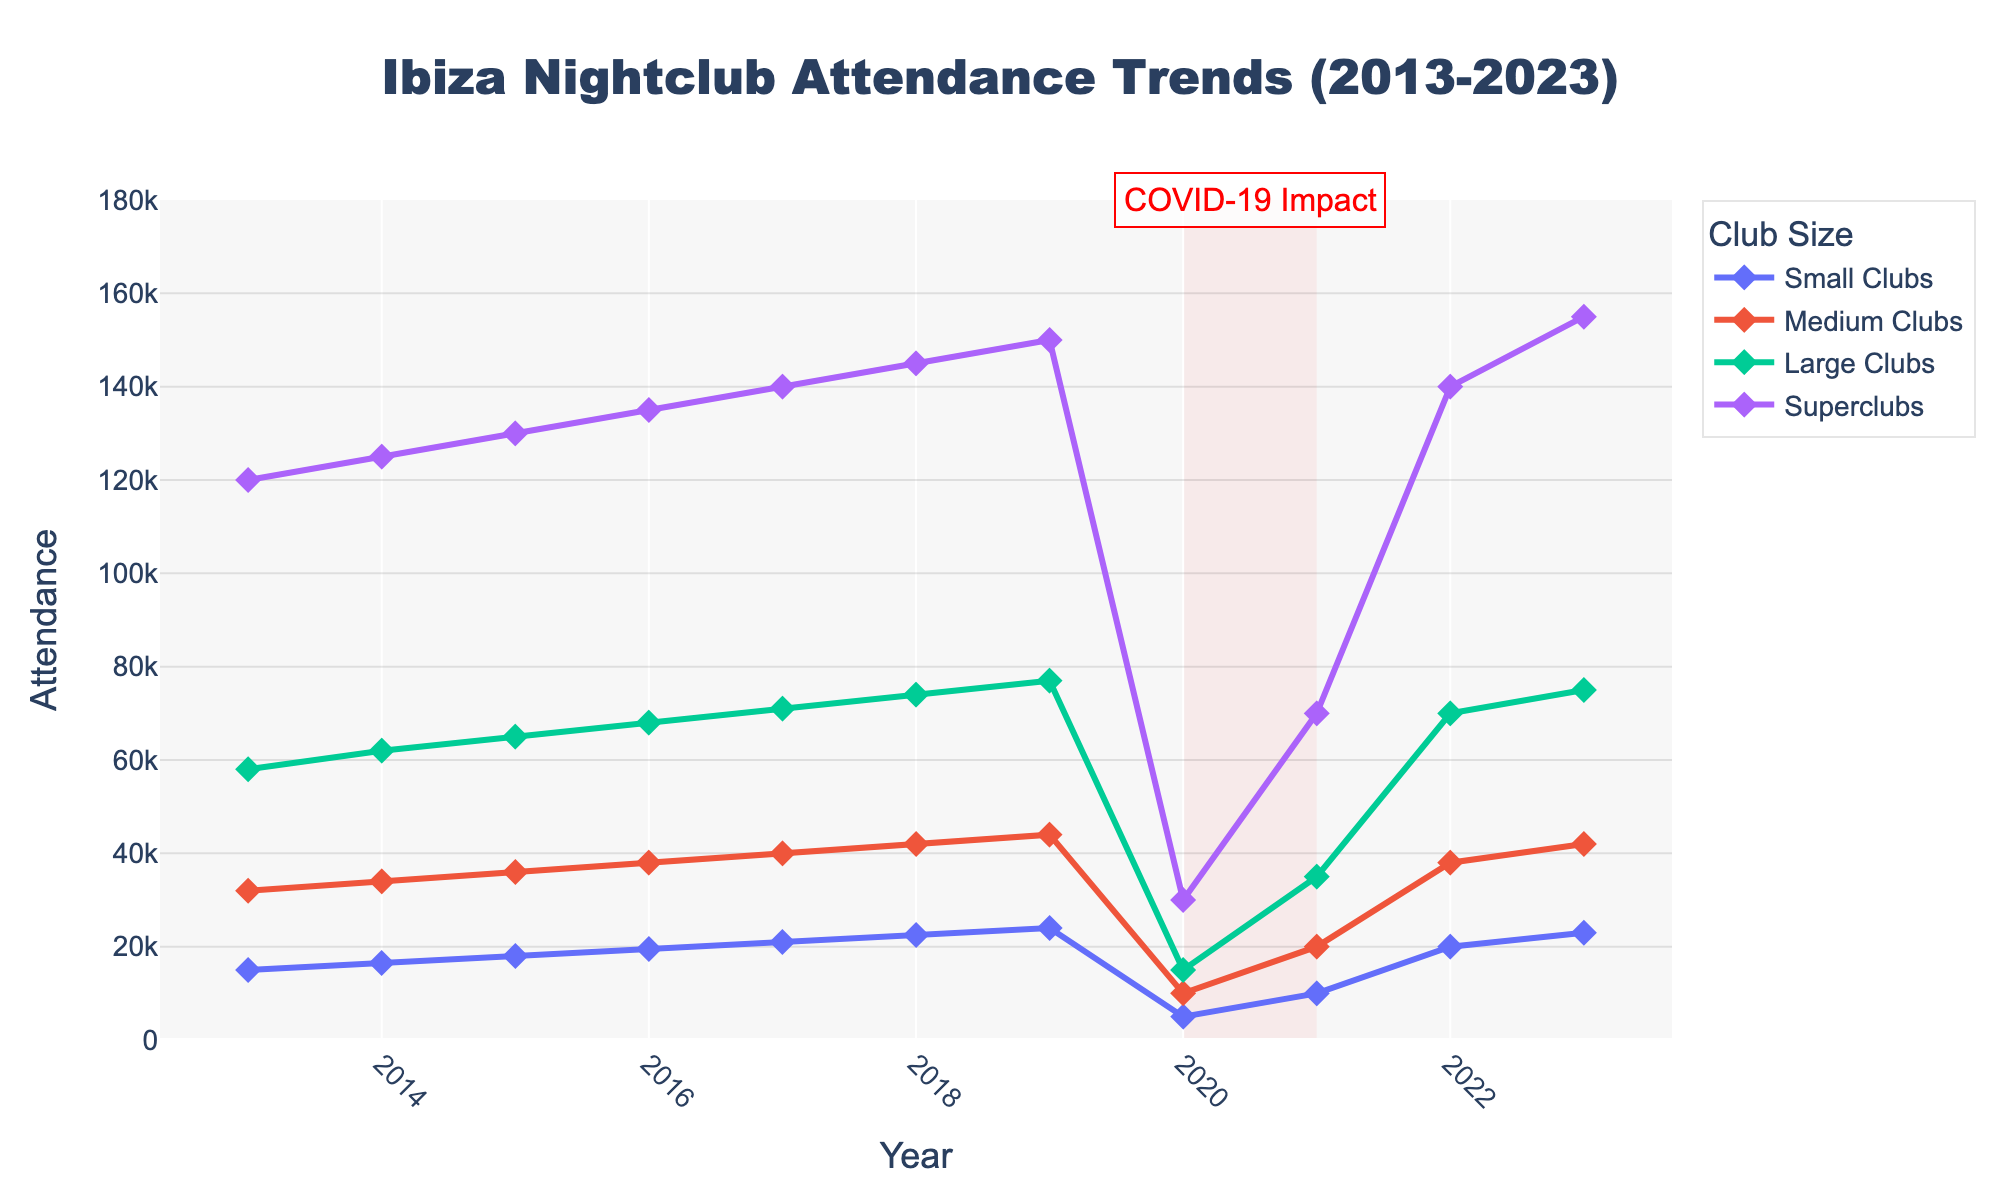What year saw the highest attendance in superclubs? By closely observing the line representing superclubs, we can see that the attendance peaks in 2023.
Answer: 2023 How did the attendance of small clubs change from 2020 to 2021? By examining the plot, the attendance of small clubs rose from 5000 in 2020 to 10000 in 2021.
Answer: Increased What is the difference in attendance between medium clubs and large clubs in 2023? From the chart, the attendance in 2023 is 42000 for medium clubs and 75000 for large clubs. Calculating the difference: 75000 - 42000 = 33000.
Answer: 33000 Which club size had the most significant drop in attendance during the COVID-19 impact period (2020-2021)? By analyzing the attendance lines during 2020-2021, medium clubs dropped from 10000 to 20000, large clubs from 15000 to 35000, but superclubs dropped from 30000 to 70000, the highest change.
Answer: Superclubs What is the average attendance of small clubs from 2013 to 2023? Summing up the attendance for small clubs: 15000 + 16500 + 18000 + 19500 + 21000 + 22500 + 24000 + 5000 + 10000 + 20000 + 23000 = 234500. Dividing by 11 gives the average: 234500 / 11 ≈ 21318.18.
Answer: 21318.18 In what year did medium clubs first reach an attendance of 40000 or more? Observing the medium clubs line, the attendance first reaches 40000 in 2017.
Answer: 2017 How many years saw large clubs with an attendance close to 75000? From the graph, large clubs approximately reach 75000 in 2018, 2019, 2022, and 2023 — that's 4 years.
Answer: 4 years Compare the visual heights of the lines for medium and large clubs in 2020. Which one is taller? Looking at the chart, the line for large clubs is visually higher than the medium clubs in 2020.
Answer: Large clubs Calculate the percentage growth in attendance for superclubs from 2019 to 2023. The attendance in 2019 was 150000 and in 2023 it was 155000. The growth can be calculated by: ((155000 - 150000) / 150000) * 100 ≈ 3.33%.
Answer: 3.33% What is the ratio of superclubs' attendance to small clubs' attendance in 2022? The attendance in 2022 for superclubs is 140000 and for small clubs is 20000. The ratio is 140000 / 20000 = 7.
Answer: 7 